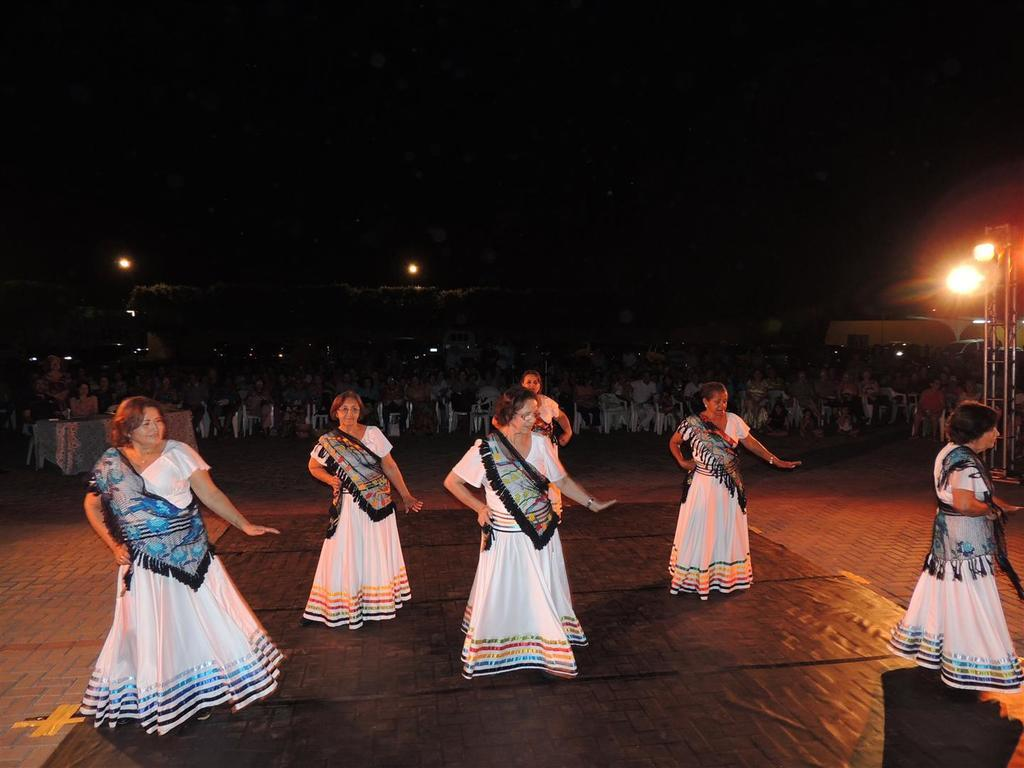What are the persons in the image doing? The persons in the image are dancing on the floor. Can you describe the atmosphere in the image? There is a crowd in the image, which suggests a lively and social environment. What type of furniture can be seen in the image? There are tables in the image. What structures are present in the image? There are poles in the image. What can be seen illuminating the scene? There are lights in the image. How would you describe the lighting conditions in the image? The background of the image is dark, which suggests that the lights are providing the primary source of illumination. What type of zephyr can be seen blowing through the image? There is no zephyr present in the image; it is an indoor scene with no visible wind or breeze. What kind of cracker is being passed around in the image? There is no cracker present in the image; the focus is on the dancing and the crowd. 